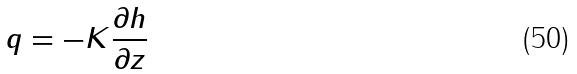<formula> <loc_0><loc_0><loc_500><loc_500>q = - K \frac { \partial h } { \partial z }</formula> 